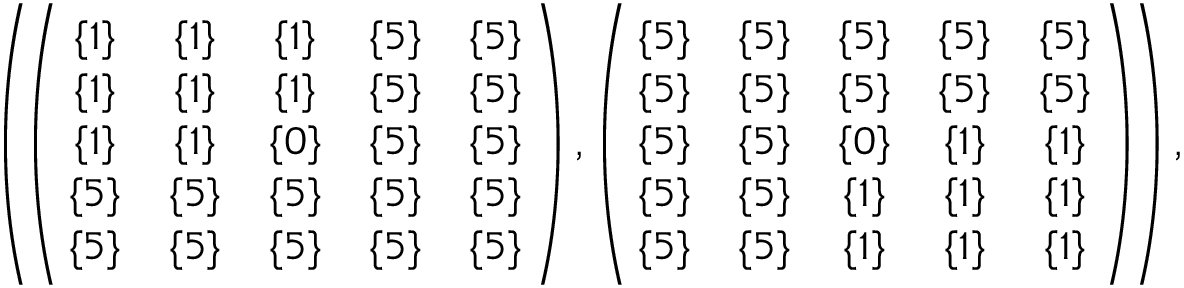Convert formula to latex. <formula><loc_0><loc_0><loc_500><loc_500>\begin{array} { r } { \left ( \, \left ( \, \begin{array} { c c c c c } { \{ 1 \} } & { \{ 1 \} } & { \{ 1 \} } & { \{ 5 \} } & { \{ 5 \} } \\ { \{ 1 \} } & { \{ 1 \} } & { \{ 1 \} } & { \{ 5 \} } & { \{ 5 \} } \\ { \{ 1 \} } & { \{ 1 \} } & { \{ 0 \} } & { \{ 5 \} } & { \{ 5 \} } \\ { \{ 5 \} } & { \{ 5 \} } & { \{ 5 \} } & { \{ 5 \} } & { \{ 5 \} } \\ { \{ 5 \} } & { \{ 5 \} } & { \{ 5 \} } & { \{ 5 \} } & { \{ 5 \} } \end{array} \, \right ) , \left ( \, \begin{array} { c c c c c } { \{ 5 \} } & { \{ 5 \} } & { \{ 5 \} } & { \{ 5 \} } & { \{ 5 \} } \\ { \{ 5 \} } & { \{ 5 \} } & { \{ 5 \} } & { \{ 5 \} } & { \{ 5 \} } \\ { \{ 5 \} } & { \{ 5 \} } & { \{ 0 \} } & { \{ 1 \} } & { \{ 1 \} } \\ { \{ 5 \} } & { \{ 5 \} } & { \{ 1 \} } & { \{ 1 \} } & { \{ 1 \} } \\ { \{ 5 \} } & { \{ 5 \} } & { \{ 1 \} } & { \{ 1 \} } & { \{ 1 \} } \end{array} \, \right ) \, \right ) , } \end{array}</formula> 